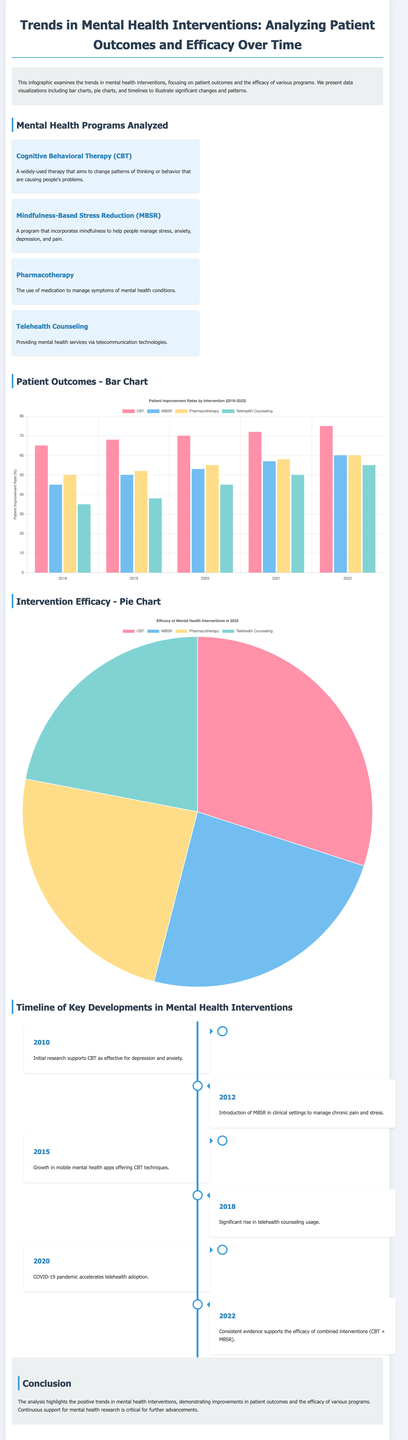What is the title of the infographic? The title of the infographic is shown at the top and reads "Trends in Mental Health Interventions: Analyzing Patient Outcomes and Efficacy Over Time."
Answer: Trends in Mental Health Interventions: Analyzing Patient Outcomes and Efficacy Over Time Which mental health intervention had the highest patient improvement rate in 2022? The bar chart indicates that Cognitive Behavioral Therapy had the highest patient improvement rate with a value of 75%.
Answer: Cognitive Behavioral Therapy What year saw the significant rise in telehealth counseling usage? The timeline specifies that the significant rise in telehealth counseling usage occurred in 2018.
Answer: 2018 What percentage of people found Cognitive Behavioral Therapy effective in 2022? The pie chart shows that 75% of people found Cognitive Behavioral Therapy effective in 2022.
Answer: 75% What were the two interventions combined in 2022 that showed consistent evidence of efficacy? The timeline implies that the combined interventions were Cognitive Behavioral Therapy and Mindfulness-Based Stress Reduction.
Answer: Cognitive Behavioral Therapy and Mindfulness-Based Stress Reduction How many mental health programs were analyzed in the document? The document lists four specific mental health programs under the section "Mental Health Programs Analyzed."
Answer: Four What is the lowest percentage of efficacy among the interventions listed in the pie chart? The pie chart indicates that Telehealth Counseling had the lowest percentage of efficacy at 55%.
Answer: 55% Which year marked the initial research supporting Cognitive Behavioral Therapy as effective? According to the timeline, the initial research supporting CBT was in 2010.
Answer: 2010 What type of chart represents patient outcomes in the document? The document uses a bar chart to depict patient outcomes from various mental health interventions.
Answer: Bar Chart 